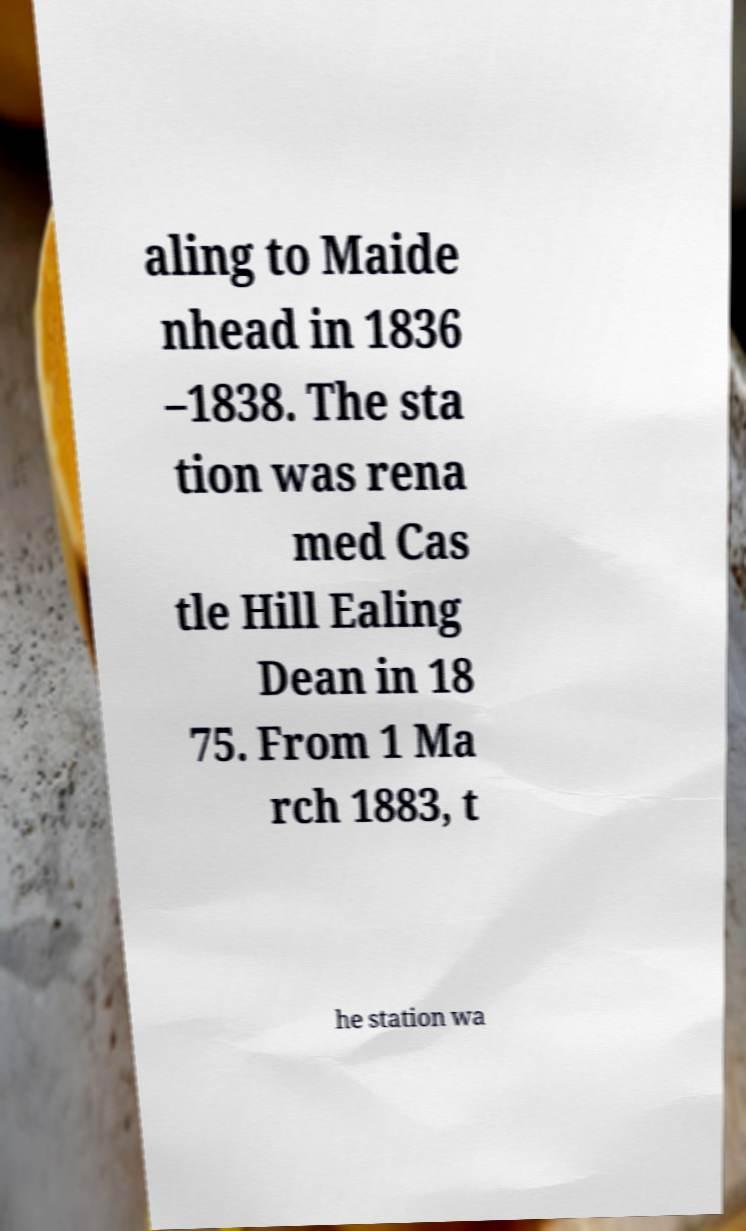I need the written content from this picture converted into text. Can you do that? aling to Maide nhead in 1836 –1838. The sta tion was rena med Cas tle Hill Ealing Dean in 18 75. From 1 Ma rch 1883, t he station wa 